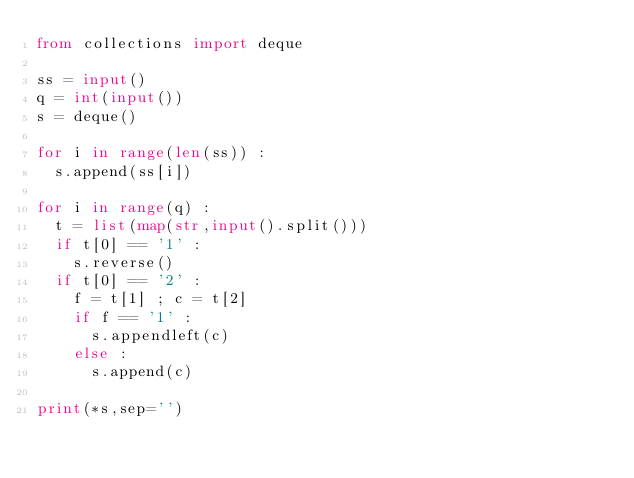<code> <loc_0><loc_0><loc_500><loc_500><_Python_>from collections import deque

ss = input()
q = int(input())
s = deque()

for i in range(len(ss)) :
  s.append(ss[i])

for i in range(q) :
  t = list(map(str,input().split()))
  if t[0] == '1' :
    s.reverse()
  if t[0] == '2' :
    f = t[1] ; c = t[2]
    if f == '1' :
      s.appendleft(c)
    else :
      s.append(c)
      
print(*s,sep='')</code> 